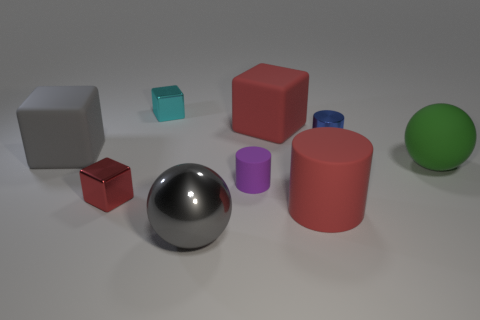Subtract all large gray matte blocks. How many blocks are left? 3 Add 1 tiny cyan metallic objects. How many objects exist? 10 Subtract all gray balls. How many red blocks are left? 2 Subtract all gray cubes. How many cubes are left? 3 Subtract all cubes. How many objects are left? 5 Subtract all blue blocks. Subtract all red balls. How many blocks are left? 4 Subtract all cyan metallic things. Subtract all big gray objects. How many objects are left? 6 Add 1 blue shiny cylinders. How many blue shiny cylinders are left? 2 Add 3 big blue metallic cylinders. How many big blue metallic cylinders exist? 3 Subtract 0 purple spheres. How many objects are left? 9 